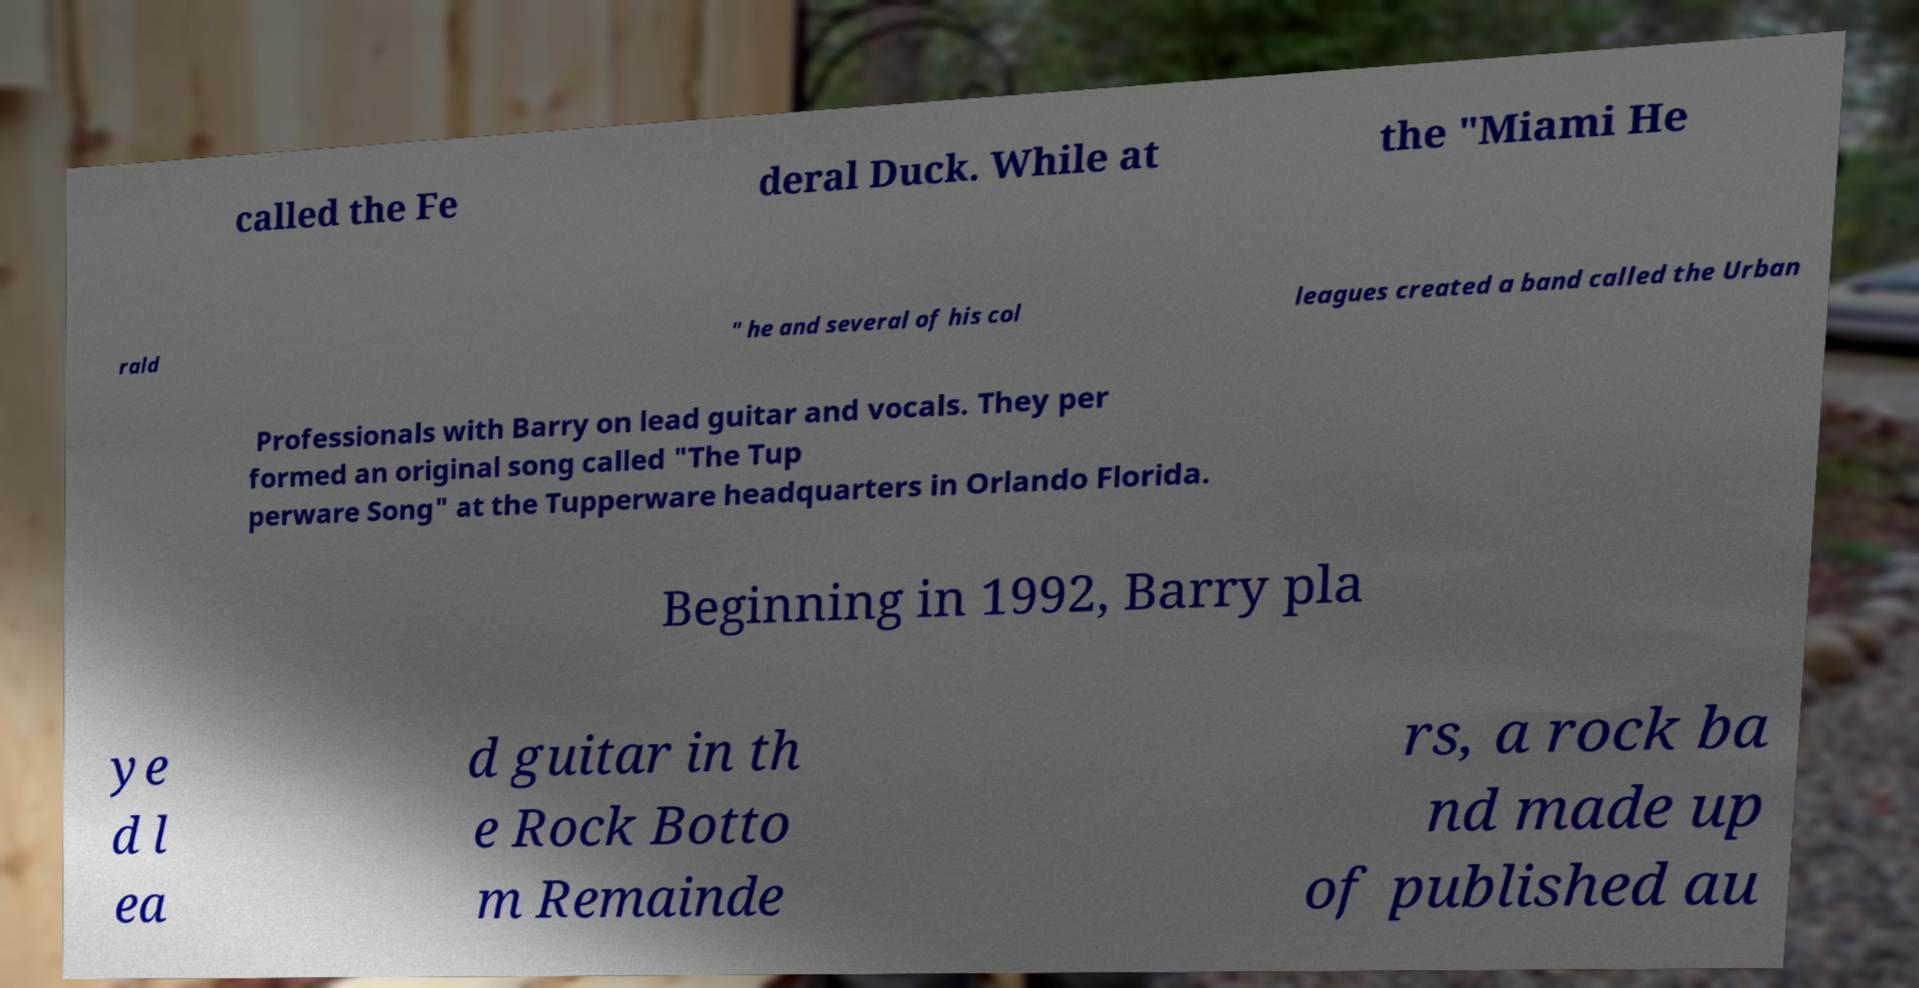There's text embedded in this image that I need extracted. Can you transcribe it verbatim? called the Fe deral Duck. While at the "Miami He rald " he and several of his col leagues created a band called the Urban Professionals with Barry on lead guitar and vocals. They per formed an original song called "The Tup perware Song" at the Tupperware headquarters in Orlando Florida. Beginning in 1992, Barry pla ye d l ea d guitar in th e Rock Botto m Remainde rs, a rock ba nd made up of published au 